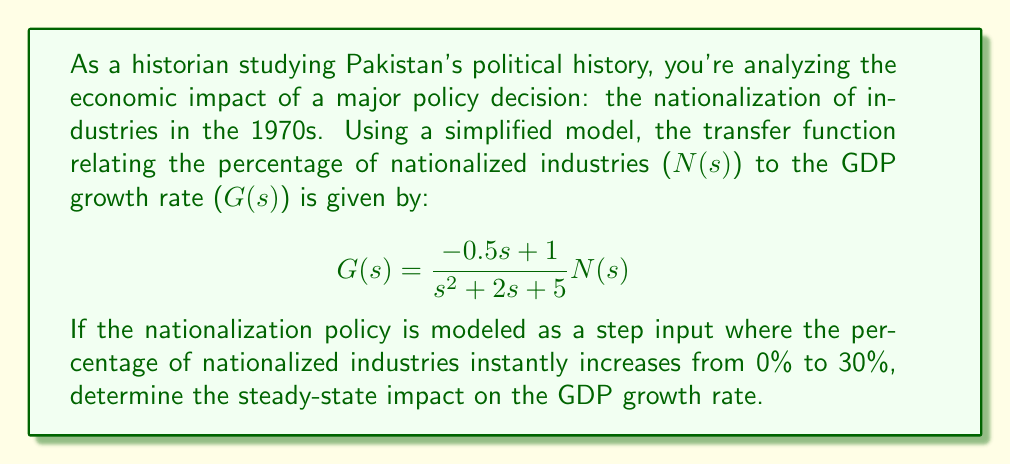Can you solve this math problem? To solve this problem, we'll follow these steps:

1) First, recall that for a step input, the Laplace transform is $\frac{A}{s}$, where A is the magnitude of the step. In this case, A = 30 (representing 30%).

2) The transfer function is given as:

   $$G(s) = \frac{-0.5s + 1}{s^2 + 2s + 5} N(s)$$

3) Multiply this by the input $\frac{30}{s}$:

   $$G(s) = \frac{-0.5s + 1}{s^2 + 2s + 5} \cdot \frac{30}{s}$$

4) To find the steady-state response, we need to apply the Final Value Theorem. This states that for a stable system, the steady-state value is:

   $$\lim_{t \to \infty} g(t) = \lim_{s \to 0} sG(s)$$

5) Let's apply this:

   $$\lim_{s \to 0} s \cdot \frac{-0.5s + 1}{s^2 + 2s + 5} \cdot \frac{30}{s}$$

6) Simplify:

   $$\lim_{s \to 0} \frac{30(-0.5s + 1)}{s^2 + 2s + 5}$$

7) As $s$ approaches 0, this becomes:

   $$\frac{30 \cdot 1}{5} = 6$$

Therefore, the steady-state impact on the GDP growth rate is 6%.
Answer: The steady-state impact on the GDP growth rate is 6%. 